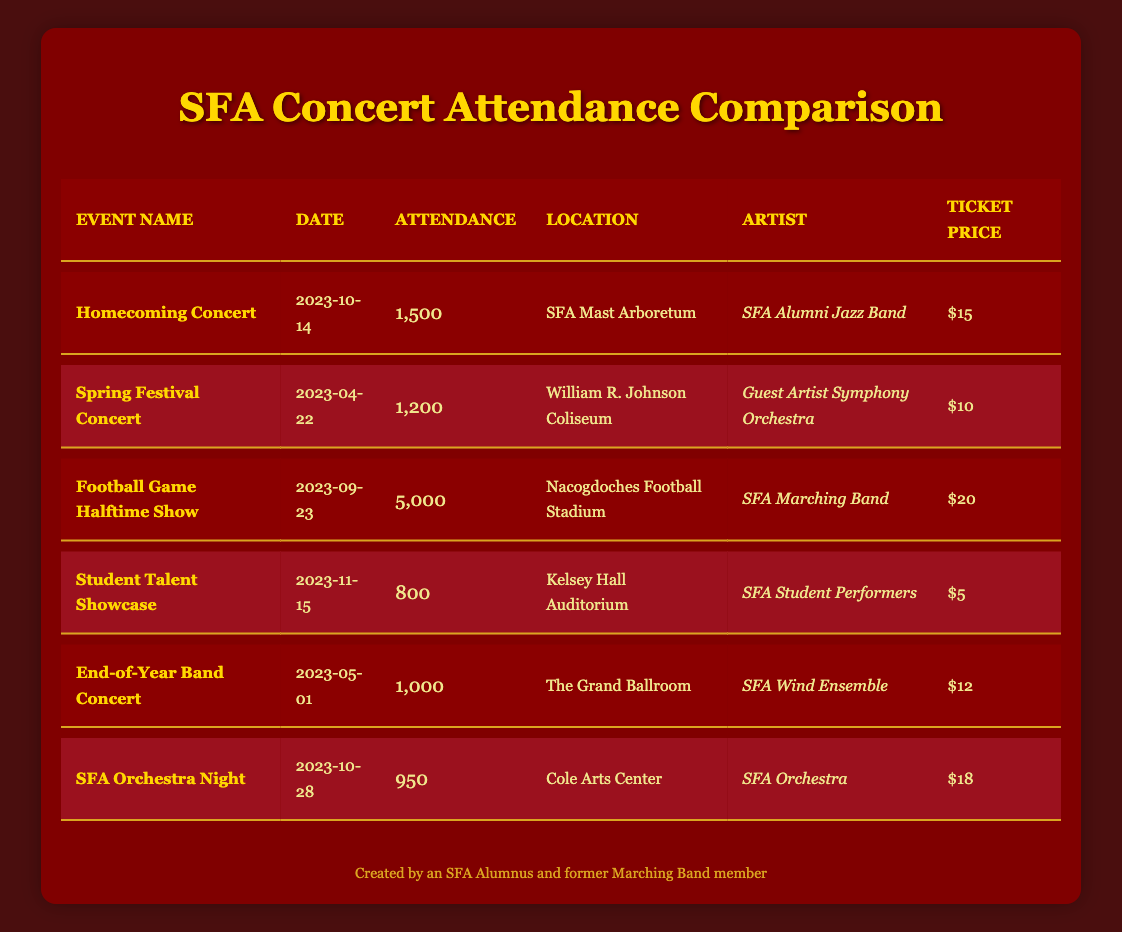What's the date of the Homecoming Concert? The date is listed under the "Date" column for the event "Homecoming Concert". It states "2023-10-14".
Answer: 2023-10-14 Which artist performed at the Football Game Halftime Show? The artist is noted in the "Artist" column for the event "Football Game Halftime Show", which is "SFA Marching Band".
Answer: SFA Marching Band How much was the ticket price for the Spring Festival Concert? The ticket price can be found in the "Ticket Price" column under the "Spring Festival Concert" row. It shows "$10".
Answer: $10 What is the total attendance across all events? To find the total attendance, add the attendance figures for all events: 1500 + 1200 + 5000 + 800 + 1000 + 950 = 10000.
Answer: 10000 Is the attendance for the SFA Orchestra Night greater than the End-of-Year Band Concert? Comparing the attendance figures from both events: SFA Orchestra Night has 950 attendees and the End-of-Year Band Concert has 1000 attendees, so 950 is not greater than 1000.
Answer: No What is the average ticket price for all concerts? To calculate the average ticket price: first, sum the ticket prices ($15 + $10 + $20 + $5 + $12 + $18 = $90). Then, divide by the number of events (6). So, the average ticket price is $90/6 = $15.
Answer: $15 Which concert had the highest attendance? The attendance figures must be reviewed to identify the maximum: Football Game Halftime Show has 5000 attendees, which is greater than all other events.
Answer: Football Game Halftime Show Was the Student Talent Showcase ticket price lower than the SFA Orchestra Night? The Student Talent Showcase has a ticket price of $5, while SFA Orchestra Night's price is $18. Since $5 is lower than $18, the answer is yes.
Answer: Yes What percentage of the total attendance did the Homecoming Concert represent? To find the percentage, divide the Homecoming Concert attendance (1500) by the total attendance (10000), then multiply by 100. So, (1500/10000) * 100 = 15%.
Answer: 15% 